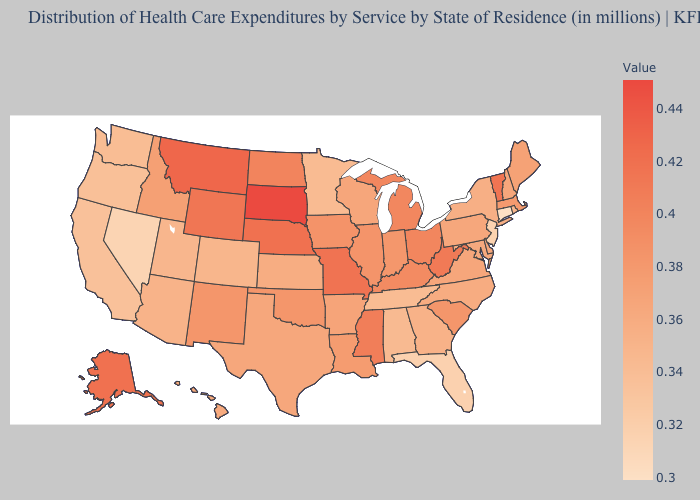Does South Dakota have the highest value in the USA?
Be succinct. Yes. Does West Virginia have the highest value in the South?
Keep it brief. Yes. Is the legend a continuous bar?
Keep it brief. Yes. Does South Dakota have the highest value in the USA?
Answer briefly. Yes. Does Idaho have a higher value than Mississippi?
Concise answer only. No. Which states have the highest value in the USA?
Short answer required. South Dakota. Among the states that border Missouri , which have the highest value?
Be succinct. Nebraska. 